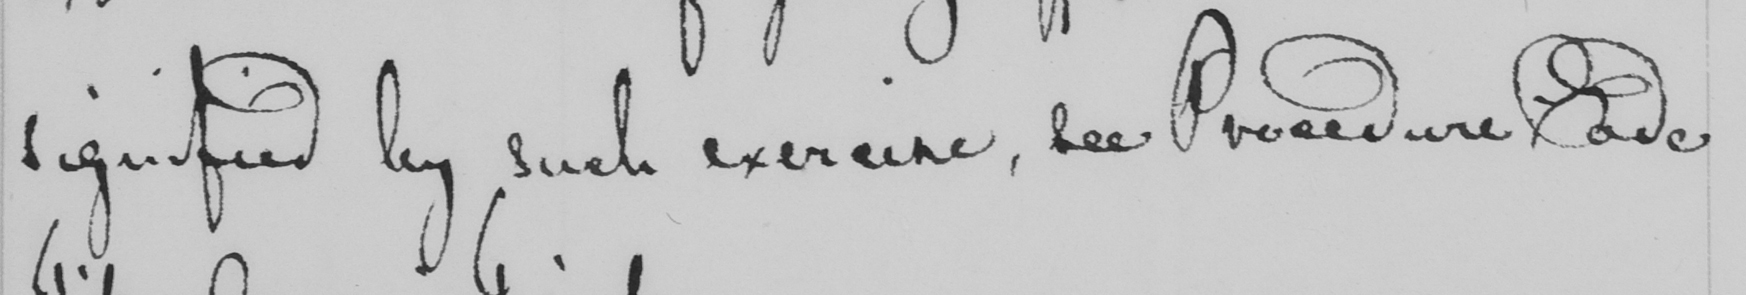Please transcribe the handwritten text in this image. signified by such experience , see Procedure Code 